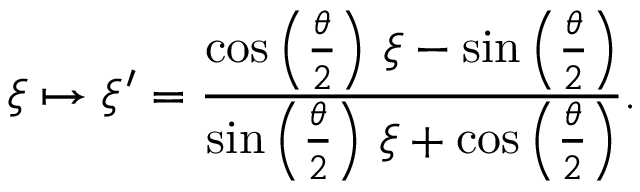<formula> <loc_0><loc_0><loc_500><loc_500>\xi \mapsto \xi ^ { \prime } = { \frac { \cos \left ( { \frac { \theta } { 2 } } \right ) \, \xi - \sin \left ( { \frac { \theta } { 2 } } \right ) } { \sin \left ( { \frac { \theta } { 2 } } \right ) \, \xi + \cos \left ( { \frac { \theta } { 2 } } \right ) } } .</formula> 